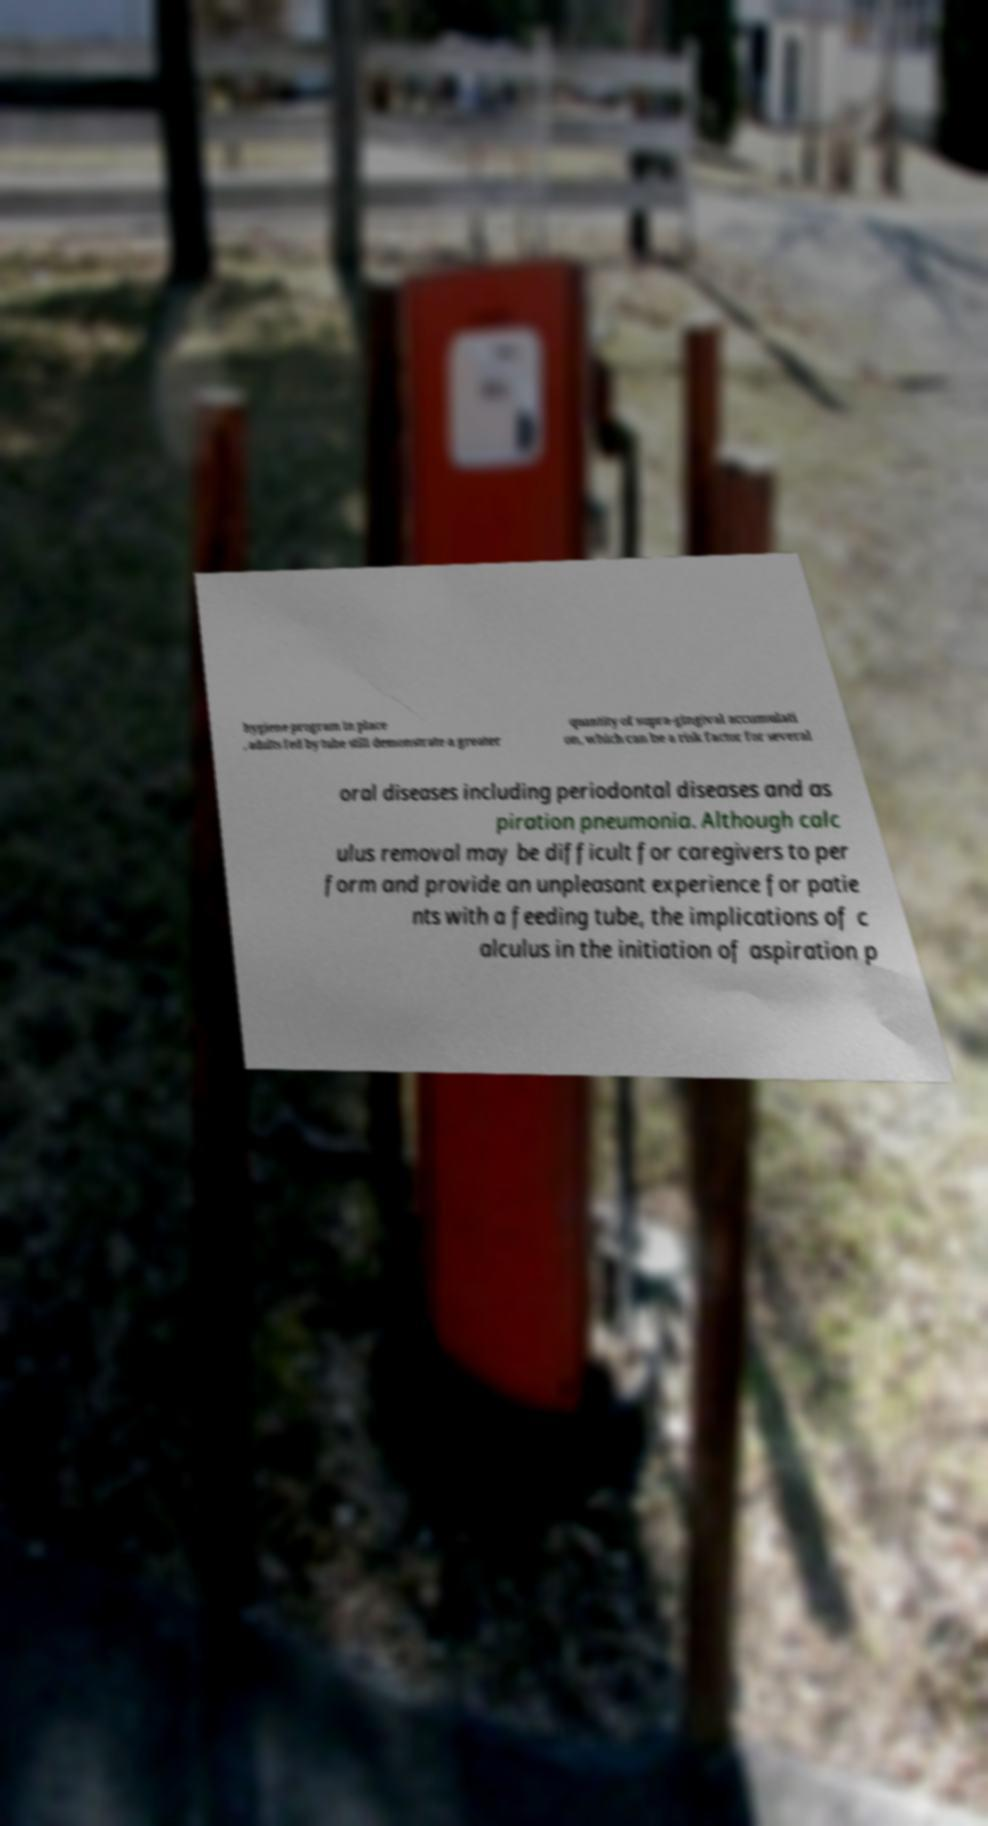Could you extract and type out the text from this image? hygiene program in place , adults fed by tube still demonstrate a greater quantity of supra-gingival accumulati on, which can be a risk factor for several oral diseases including periodontal diseases and as piration pneumonia. Although calc ulus removal may be difficult for caregivers to per form and provide an unpleasant experience for patie nts with a feeding tube, the implications of c alculus in the initiation of aspiration p 